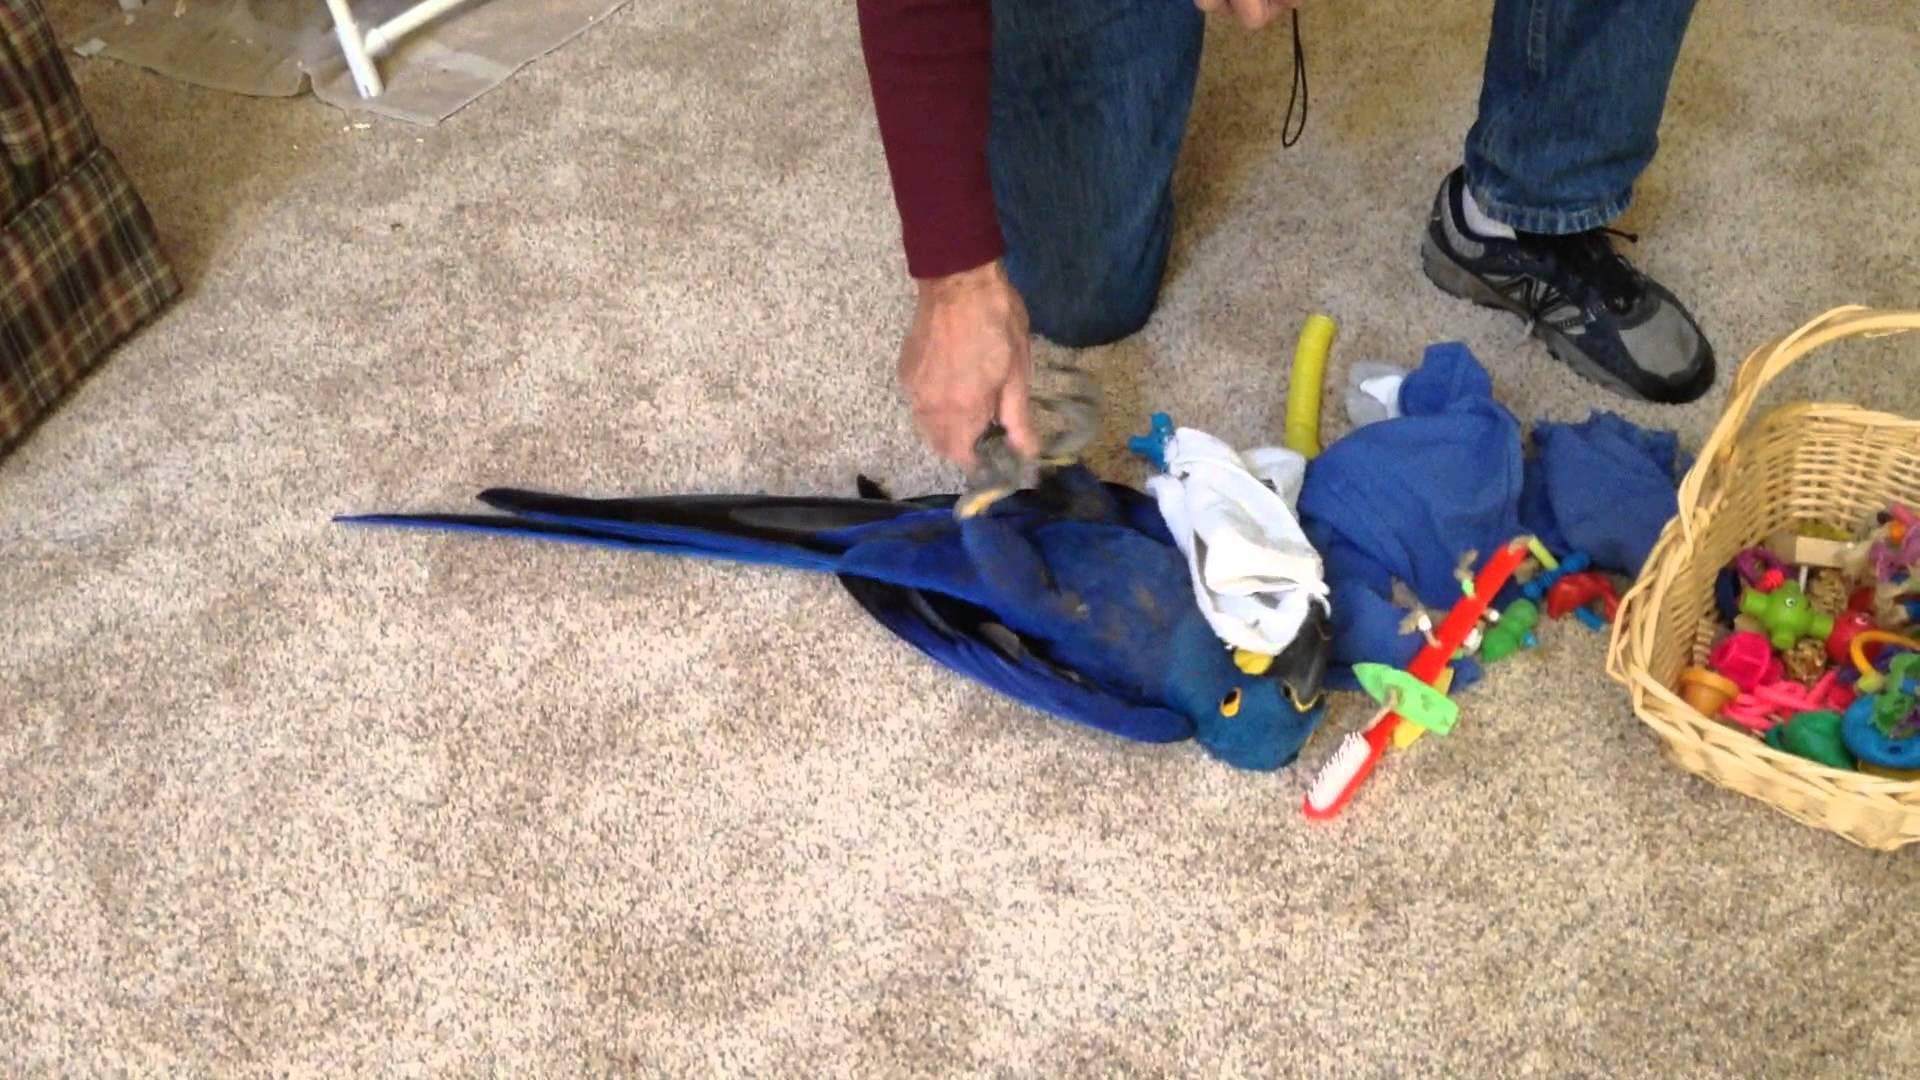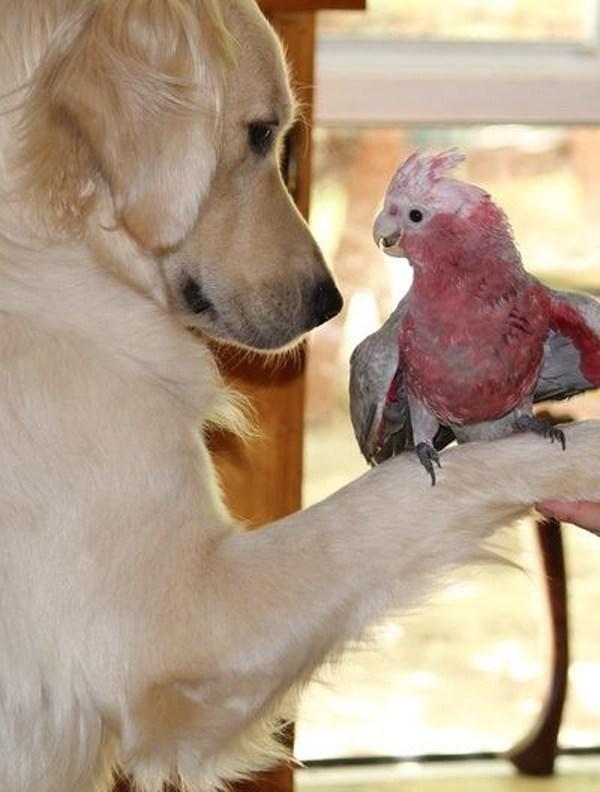The first image is the image on the left, the second image is the image on the right. Evaluate the accuracy of this statement regarding the images: "There are two dogs and a macaw standing on carpet together in one image.". Is it true? Answer yes or no. No. The first image is the image on the left, the second image is the image on the right. For the images displayed, is the sentence "A german shepherd plays with a blue and gold macaw." factually correct? Answer yes or no. No. 